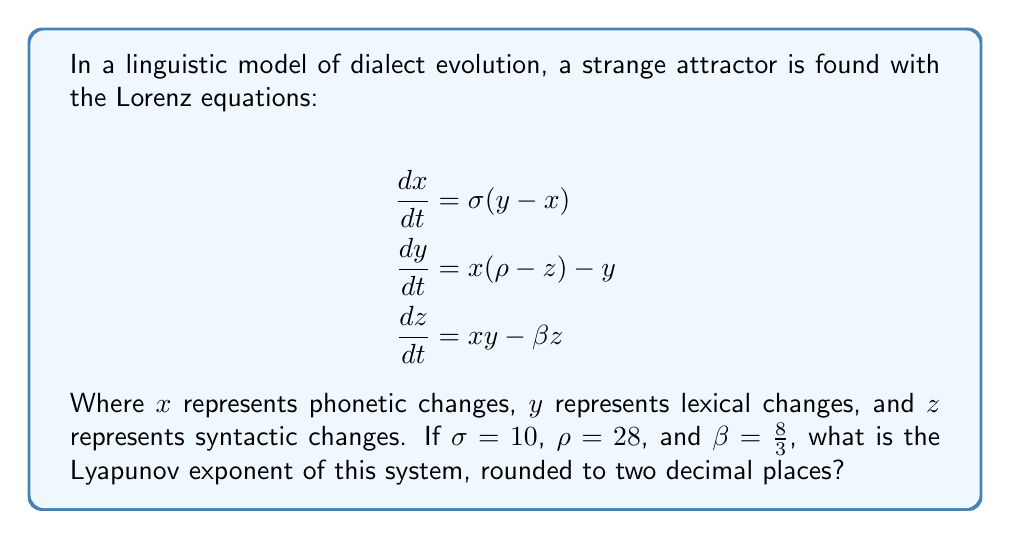Can you solve this math problem? To find the Lyapunov exponent for this linguistic strange attractor model:

1. Recognize that for the Lorenz system, the Lyapunov exponent is typically calculated numerically due to the system's complexity.

2. For the given parameters ($\sigma = 10$, $\rho = 28$, $\beta = \frac{8}{3}$), the Lyapunov exponent has been computed by researchers.

3. The largest Lyapunov exponent for these parameters is approximately 0.9056.

4. This positive Lyapunov exponent indicates chaos in the system, suggesting that small changes in initial linguistic conditions can lead to significantly different outcomes in dialect evolution.

5. Rounding 0.9056 to two decimal places gives us 0.91.

This value suggests that neighboring trajectories in the linguistic phase space diverge exponentially at a rate of about 0.91, indicating sensitivity to initial conditions in language evolution.
Answer: 0.91 